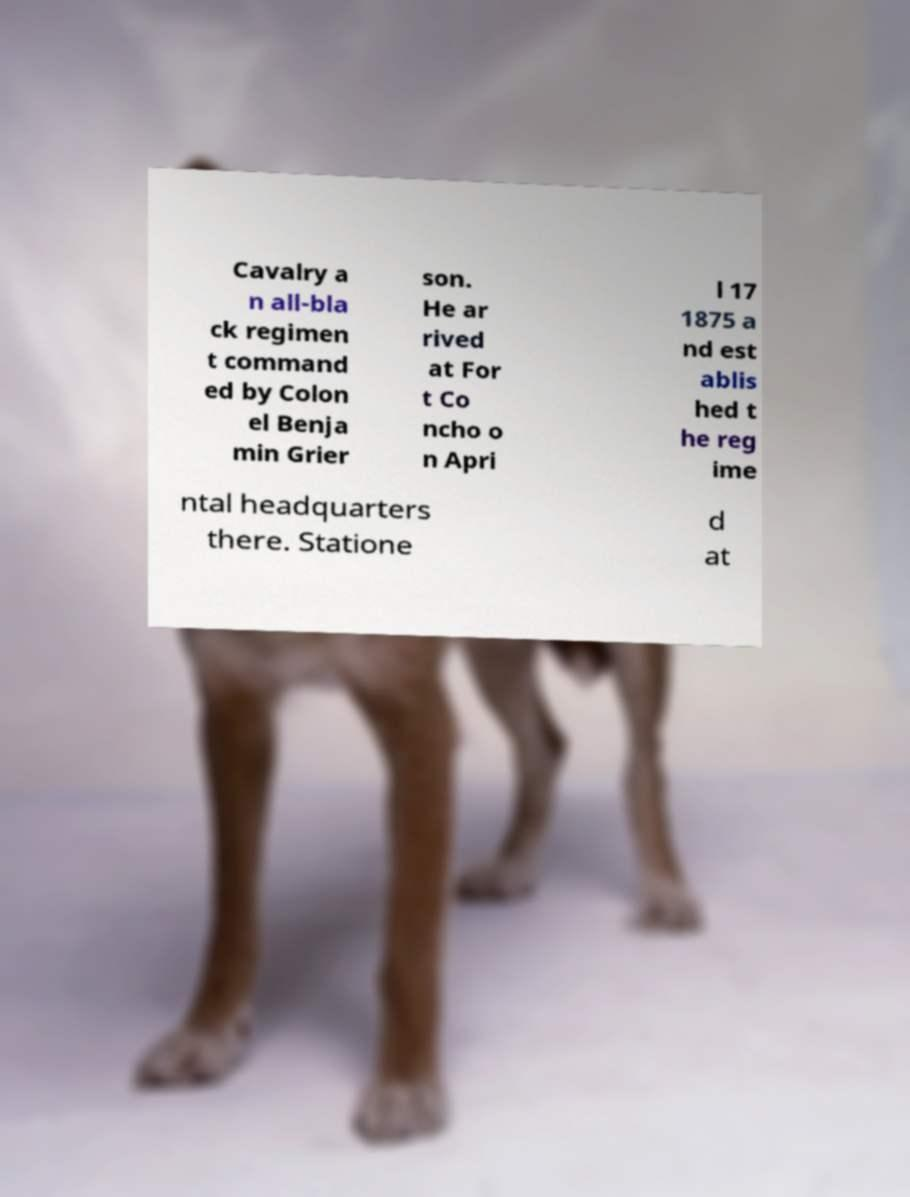For documentation purposes, I need the text within this image transcribed. Could you provide that? Cavalry a n all-bla ck regimen t command ed by Colon el Benja min Grier son. He ar rived at For t Co ncho o n Apri l 17 1875 a nd est ablis hed t he reg ime ntal headquarters there. Statione d at 